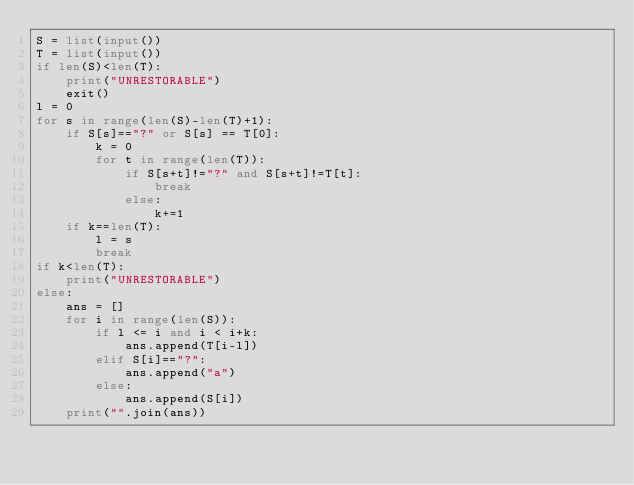Convert code to text. <code><loc_0><loc_0><loc_500><loc_500><_Python_>S = list(input())
T = list(input())
if len(S)<len(T):
    print("UNRESTORABLE")
    exit()
l = 0
for s in range(len(S)-len(T)+1):
    if S[s]=="?" or S[s] == T[0]:
        k = 0
        for t in range(len(T)):
            if S[s+t]!="?" and S[s+t]!=T[t]:
                break
            else:
                k+=1
    if k==len(T):
        l = s
        break
if k<len(T):
    print("UNRESTORABLE")
else:
    ans = []
    for i in range(len(S)):
        if l <= i and i < i+k:
            ans.append(T[i-l])
        elif S[i]=="?":
            ans.append("a")
        else:
            ans.append(S[i])
    print("".join(ans))</code> 